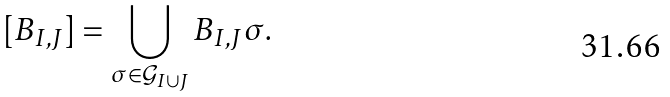Convert formula to latex. <formula><loc_0><loc_0><loc_500><loc_500>[ B _ { I , J } ] = \bigcup _ { \sigma \in \mathcal { G } _ { I \cup J } } B _ { I , J } \sigma .</formula> 